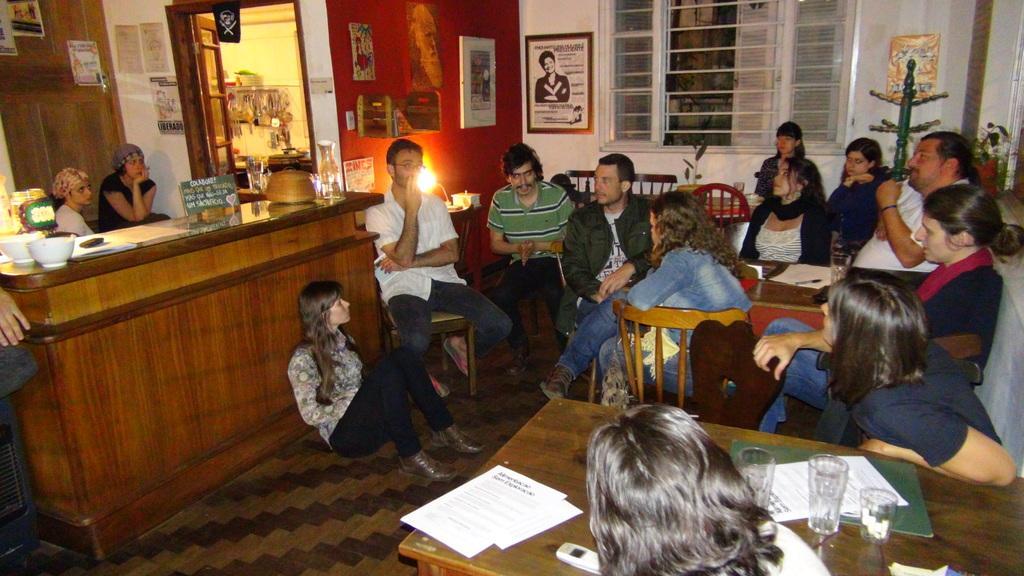How would you summarize this image in a sentence or two? In this image I can see number of people are sitting on chairs. Here on table I can see few glasses and few papers. In the background I can see few frames on these walls. 